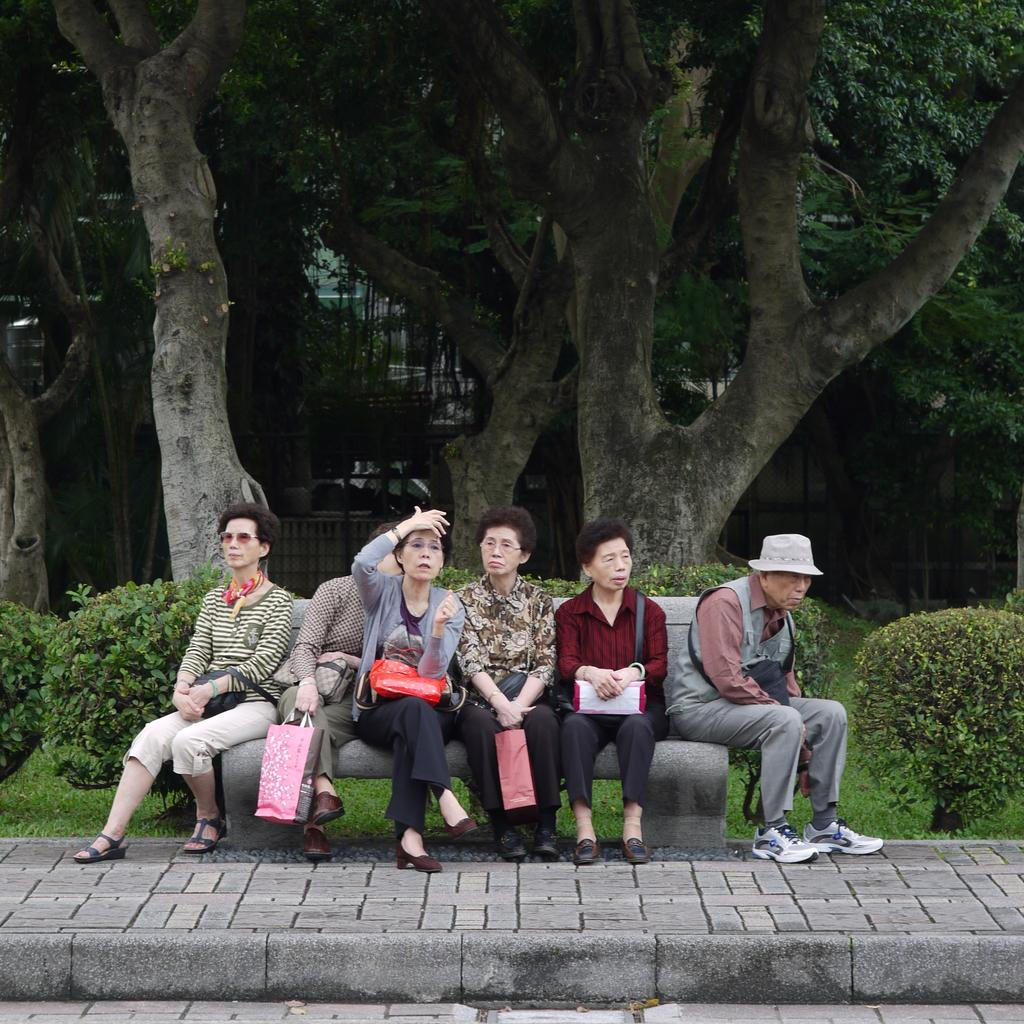What are the people in the image doing? The people in the image are sitting on a bench in the center of the image. What is the surface beneath the bench? There is a pavement at the bottom of the image. What can be seen in the background of the image? There are trees, at least one building, plants, and grass visible in the background of the image. What type of badge is the person wearing in the image? There are no people wearing badges in the image; they are simply sitting on a bench. 